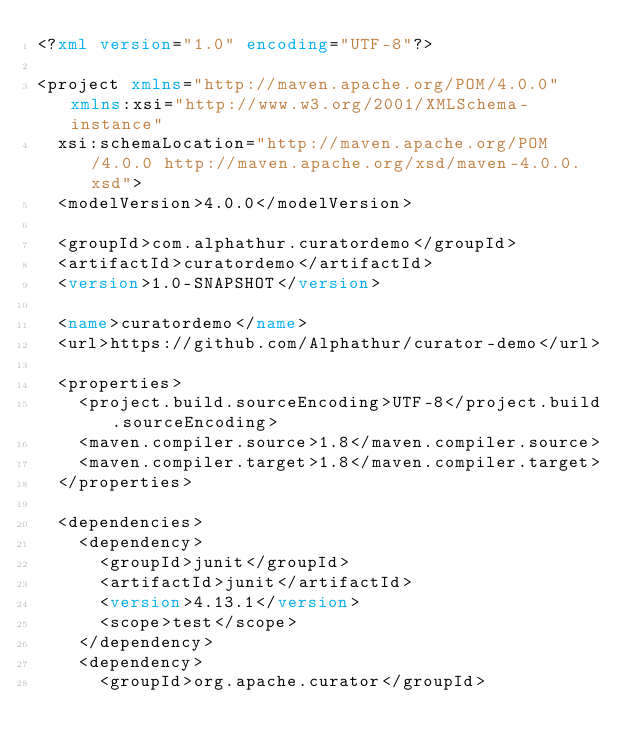Convert code to text. <code><loc_0><loc_0><loc_500><loc_500><_XML_><?xml version="1.0" encoding="UTF-8"?>

<project xmlns="http://maven.apache.org/POM/4.0.0" xmlns:xsi="http://www.w3.org/2001/XMLSchema-instance"
  xsi:schemaLocation="http://maven.apache.org/POM/4.0.0 http://maven.apache.org/xsd/maven-4.0.0.xsd">
  <modelVersion>4.0.0</modelVersion>

  <groupId>com.alphathur.curatordemo</groupId>
  <artifactId>curatordemo</artifactId>
  <version>1.0-SNAPSHOT</version>

  <name>curatordemo</name>
  <url>https://github.com/Alphathur/curator-demo</url>

  <properties>
    <project.build.sourceEncoding>UTF-8</project.build.sourceEncoding>
    <maven.compiler.source>1.8</maven.compiler.source>
    <maven.compiler.target>1.8</maven.compiler.target>
  </properties>

  <dependencies>
    <dependency>
      <groupId>junit</groupId>
      <artifactId>junit</artifactId>
      <version>4.13.1</version>
      <scope>test</scope>
    </dependency>
    <dependency>
      <groupId>org.apache.curator</groupId></code> 